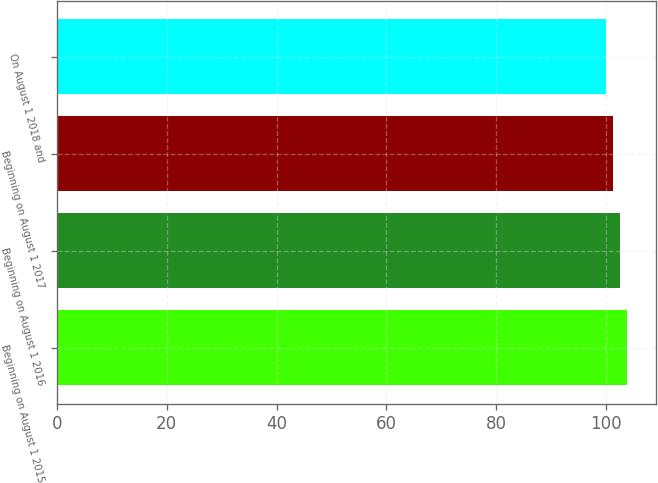Convert chart to OTSL. <chart><loc_0><loc_0><loc_500><loc_500><bar_chart><fcel>Beginning on August 1 2015<fcel>Beginning on August 1 2016<fcel>Beginning on August 1 2017<fcel>On August 1 2018 and<nl><fcel>103.88<fcel>102.58<fcel>101.29<fcel>100<nl></chart> 